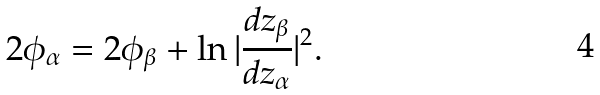Convert formula to latex. <formula><loc_0><loc_0><loc_500><loc_500>2 \phi _ { \alpha } = 2 \phi _ { \beta } + \ln | \frac { d z _ { \beta } } { d z _ { \alpha } } | ^ { 2 } .</formula> 